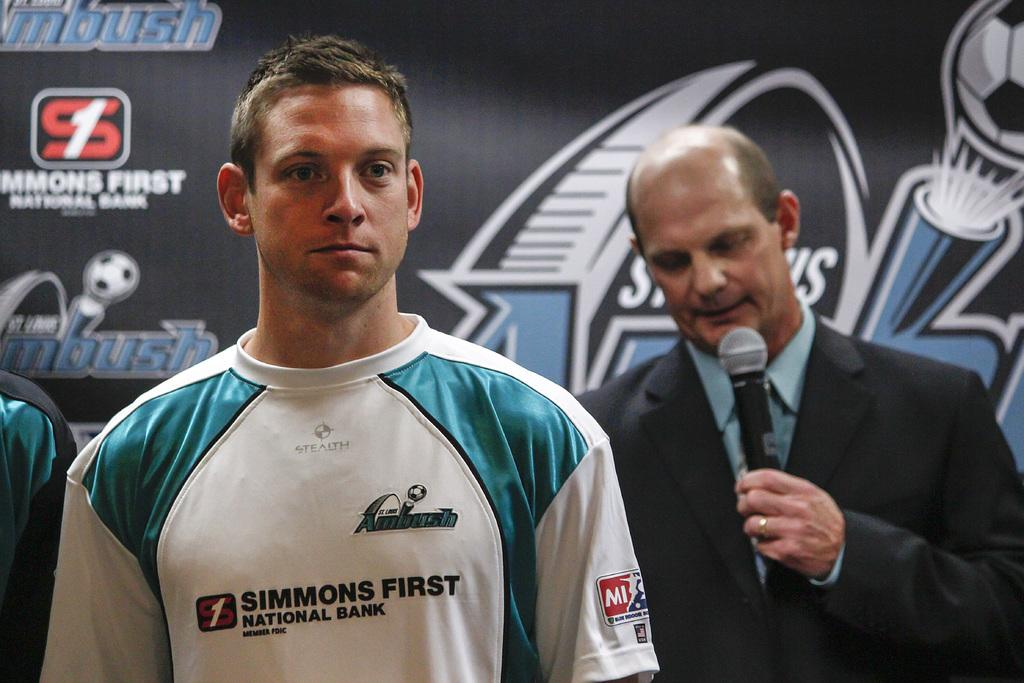<image>
Provide a brief description of the given image. A St Louis Ambush soccer players stands in front of a man in a suit holding a microphone. 